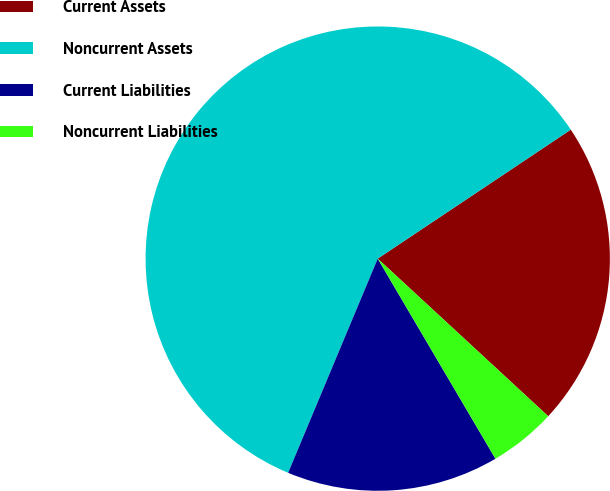Convert chart to OTSL. <chart><loc_0><loc_0><loc_500><loc_500><pie_chart><fcel>Current Assets<fcel>Noncurrent Assets<fcel>Current Liabilities<fcel>Noncurrent Liabilities<nl><fcel>21.25%<fcel>59.32%<fcel>14.77%<fcel>4.66%<nl></chart> 